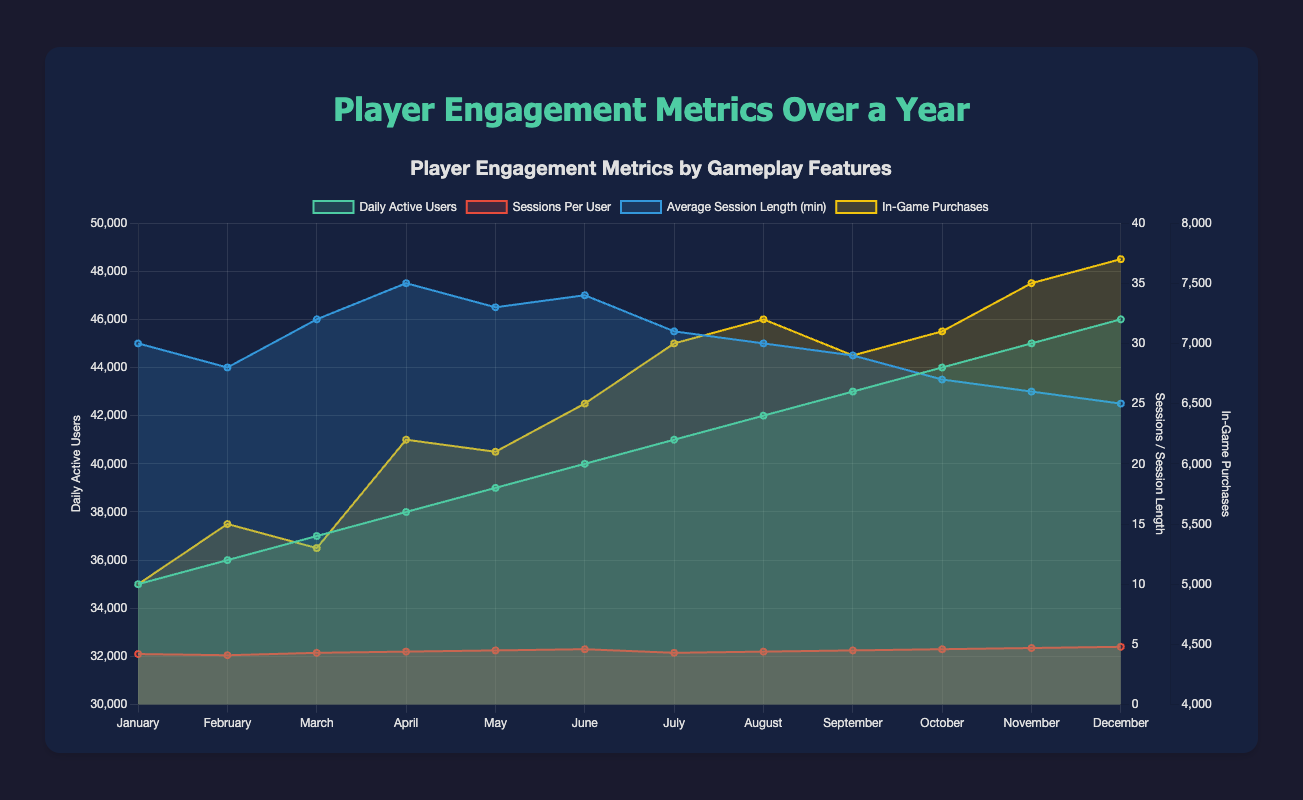What is the title of the figure? The title of the chart is displayed at the top center of the figure. It reads "Player Engagement Metrics by Gameplay Features Over a Year."
Answer: Player Engagement Metrics by Gameplay Features Over a Year In which month were the Daily Active Users the highest? By examining the area marked for "Daily Active Users," the peak is reached in December with a value of 46,000.
Answer: December How many data points are plotted for "Sessions Per User"? The x-axis lists months from January to December, and each month has one data point for the "Sessions Per User" metric. Thus, there are 12 data points.
Answer: 12 What was the average session length in April? Checking the "Average Session Length (min)" data series for the month of April, it indicates an average length of 35 minutes.
Answer: 35 minutes Which metric saw the most significant increase from January to December? Comparing the increases in the values of each metric from January to December, "Daily Active Users" increased from 35,000 to 46,000, which is the most significant absolute increase.
Answer: Daily Active Users What was the trend for "In-Game Purchases" over the year? By analyzing the data for "In-Game Purchases," the values generally rise over the 12 months, starting at 5,000 in January and ending at 7,700 in December.
Answer: Increasing trend What was the difference in ”Average Session Length (min)” between March and September? The "Average Session Length (min)" in March was 32 minutes and in September was 29 minutes. The difference between these values is 32 - 29 = 3 minutes.
Answer: 3 minutes Which month had the lowest "Sessions Per User" and what was it? Examining the "Sessions Per User" data series, the lowest value is in February with a value of 4.1 sessions per user.
Answer: February, 4.1 How do "Daily Active Users" in November compare to October? The "Daily Active Users" increased from 44,000 in October to 45,000 in November, a difference of 1,000 users.
Answer: Increased by 1,000 What was the average number of "In-Game Purchases" over the year? Summing the values [5000, 5500, 5300, 6200, 6100, 6500, 7000, 7200, 6900, 7100, 7500, 7700] and dividing by the 12 months: (5000+5500+5300+6200+6100+6500+7000+7200+6900+7100+7500+7700)/12 = 6700 purchases
Answer: 6700 purchases 